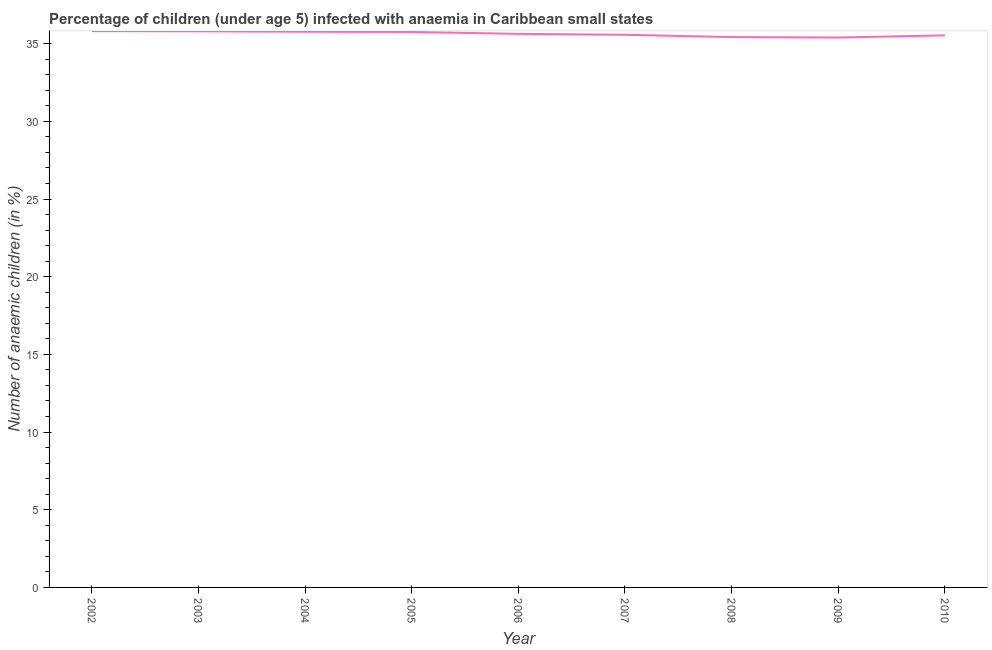What is the number of anaemic children in 2004?
Offer a very short reply. 35.77. Across all years, what is the maximum number of anaemic children?
Keep it short and to the point. 35.8. Across all years, what is the minimum number of anaemic children?
Give a very brief answer. 35.39. In which year was the number of anaemic children maximum?
Ensure brevity in your answer.  2002. What is the sum of the number of anaemic children?
Your answer should be compact. 320.66. What is the difference between the number of anaemic children in 2004 and 2005?
Provide a succinct answer. 0.01. What is the average number of anaemic children per year?
Your answer should be compact. 35.63. What is the median number of anaemic children?
Ensure brevity in your answer.  35.63. In how many years, is the number of anaemic children greater than 20 %?
Provide a succinct answer. 9. What is the ratio of the number of anaemic children in 2002 to that in 2009?
Your answer should be very brief. 1.01. Is the number of anaemic children in 2009 less than that in 2010?
Ensure brevity in your answer.  Yes. What is the difference between the highest and the second highest number of anaemic children?
Your answer should be compact. 0.01. Is the sum of the number of anaemic children in 2006 and 2008 greater than the maximum number of anaemic children across all years?
Offer a terse response. Yes. What is the difference between the highest and the lowest number of anaemic children?
Ensure brevity in your answer.  0.41. In how many years, is the number of anaemic children greater than the average number of anaemic children taken over all years?
Provide a short and direct response. 5. Does the number of anaemic children monotonically increase over the years?
Give a very brief answer. No. How many years are there in the graph?
Provide a succinct answer. 9. Are the values on the major ticks of Y-axis written in scientific E-notation?
Provide a short and direct response. No. Does the graph contain any zero values?
Provide a short and direct response. No. What is the title of the graph?
Provide a succinct answer. Percentage of children (under age 5) infected with anaemia in Caribbean small states. What is the label or title of the Y-axis?
Make the answer very short. Number of anaemic children (in %). What is the Number of anaemic children (in %) in 2002?
Ensure brevity in your answer.  35.8. What is the Number of anaemic children (in %) in 2003?
Offer a terse response. 35.79. What is the Number of anaemic children (in %) in 2004?
Your response must be concise. 35.77. What is the Number of anaemic children (in %) in 2005?
Make the answer very short. 35.75. What is the Number of anaemic children (in %) of 2006?
Your answer should be compact. 35.63. What is the Number of anaemic children (in %) of 2007?
Keep it short and to the point. 35.57. What is the Number of anaemic children (in %) of 2008?
Make the answer very short. 35.42. What is the Number of anaemic children (in %) of 2009?
Keep it short and to the point. 35.39. What is the Number of anaemic children (in %) in 2010?
Provide a succinct answer. 35.53. What is the difference between the Number of anaemic children (in %) in 2002 and 2003?
Ensure brevity in your answer.  0.01. What is the difference between the Number of anaemic children (in %) in 2002 and 2004?
Offer a very short reply. 0.04. What is the difference between the Number of anaemic children (in %) in 2002 and 2005?
Give a very brief answer. 0.05. What is the difference between the Number of anaemic children (in %) in 2002 and 2006?
Your answer should be very brief. 0.17. What is the difference between the Number of anaemic children (in %) in 2002 and 2007?
Provide a short and direct response. 0.23. What is the difference between the Number of anaemic children (in %) in 2002 and 2008?
Ensure brevity in your answer.  0.38. What is the difference between the Number of anaemic children (in %) in 2002 and 2009?
Offer a terse response. 0.41. What is the difference between the Number of anaemic children (in %) in 2002 and 2010?
Offer a terse response. 0.27. What is the difference between the Number of anaemic children (in %) in 2003 and 2004?
Your response must be concise. 0.03. What is the difference between the Number of anaemic children (in %) in 2003 and 2005?
Your response must be concise. 0.04. What is the difference between the Number of anaemic children (in %) in 2003 and 2006?
Ensure brevity in your answer.  0.17. What is the difference between the Number of anaemic children (in %) in 2003 and 2007?
Provide a succinct answer. 0.22. What is the difference between the Number of anaemic children (in %) in 2003 and 2008?
Offer a terse response. 0.37. What is the difference between the Number of anaemic children (in %) in 2003 and 2009?
Make the answer very short. 0.4. What is the difference between the Number of anaemic children (in %) in 2003 and 2010?
Provide a succinct answer. 0.26. What is the difference between the Number of anaemic children (in %) in 2004 and 2005?
Give a very brief answer. 0.01. What is the difference between the Number of anaemic children (in %) in 2004 and 2006?
Your response must be concise. 0.14. What is the difference between the Number of anaemic children (in %) in 2004 and 2007?
Ensure brevity in your answer.  0.19. What is the difference between the Number of anaemic children (in %) in 2004 and 2008?
Your answer should be very brief. 0.34. What is the difference between the Number of anaemic children (in %) in 2004 and 2009?
Provide a short and direct response. 0.37. What is the difference between the Number of anaemic children (in %) in 2004 and 2010?
Provide a short and direct response. 0.23. What is the difference between the Number of anaemic children (in %) in 2005 and 2006?
Offer a terse response. 0.12. What is the difference between the Number of anaemic children (in %) in 2005 and 2007?
Your response must be concise. 0.18. What is the difference between the Number of anaemic children (in %) in 2005 and 2008?
Give a very brief answer. 0.33. What is the difference between the Number of anaemic children (in %) in 2005 and 2009?
Keep it short and to the point. 0.36. What is the difference between the Number of anaemic children (in %) in 2005 and 2010?
Offer a very short reply. 0.22. What is the difference between the Number of anaemic children (in %) in 2006 and 2007?
Your answer should be very brief. 0.06. What is the difference between the Number of anaemic children (in %) in 2006 and 2008?
Make the answer very short. 0.21. What is the difference between the Number of anaemic children (in %) in 2006 and 2009?
Provide a succinct answer. 0.24. What is the difference between the Number of anaemic children (in %) in 2006 and 2010?
Give a very brief answer. 0.1. What is the difference between the Number of anaemic children (in %) in 2007 and 2008?
Your answer should be compact. 0.15. What is the difference between the Number of anaemic children (in %) in 2007 and 2009?
Provide a short and direct response. 0.18. What is the difference between the Number of anaemic children (in %) in 2007 and 2010?
Provide a short and direct response. 0.04. What is the difference between the Number of anaemic children (in %) in 2008 and 2009?
Provide a succinct answer. 0.03. What is the difference between the Number of anaemic children (in %) in 2008 and 2010?
Give a very brief answer. -0.11. What is the difference between the Number of anaemic children (in %) in 2009 and 2010?
Offer a terse response. -0.14. What is the ratio of the Number of anaemic children (in %) in 2002 to that in 2004?
Your answer should be very brief. 1. What is the ratio of the Number of anaemic children (in %) in 2002 to that in 2006?
Ensure brevity in your answer.  1. What is the ratio of the Number of anaemic children (in %) in 2002 to that in 2008?
Ensure brevity in your answer.  1.01. What is the ratio of the Number of anaemic children (in %) in 2003 to that in 2005?
Ensure brevity in your answer.  1. What is the ratio of the Number of anaemic children (in %) in 2003 to that in 2007?
Offer a terse response. 1.01. What is the ratio of the Number of anaemic children (in %) in 2003 to that in 2008?
Provide a succinct answer. 1.01. What is the ratio of the Number of anaemic children (in %) in 2003 to that in 2009?
Offer a terse response. 1.01. What is the ratio of the Number of anaemic children (in %) in 2003 to that in 2010?
Your answer should be compact. 1.01. What is the ratio of the Number of anaemic children (in %) in 2004 to that in 2007?
Make the answer very short. 1. What is the ratio of the Number of anaemic children (in %) in 2004 to that in 2010?
Your answer should be very brief. 1.01. What is the ratio of the Number of anaemic children (in %) in 2005 to that in 2007?
Provide a succinct answer. 1. What is the ratio of the Number of anaemic children (in %) in 2005 to that in 2008?
Make the answer very short. 1.01. What is the ratio of the Number of anaemic children (in %) in 2005 to that in 2009?
Keep it short and to the point. 1.01. What is the ratio of the Number of anaemic children (in %) in 2007 to that in 2009?
Make the answer very short. 1. 